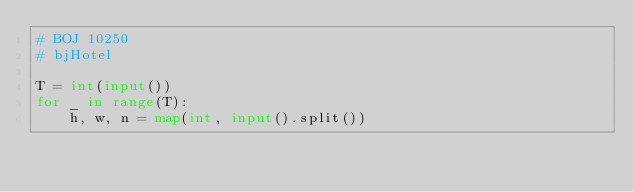Convert code to text. <code><loc_0><loc_0><loc_500><loc_500><_Python_># BOJ 10250
# bjHotel

T = int(input())
for _ in range(T):
    h, w, n = map(int, input().split())</code> 